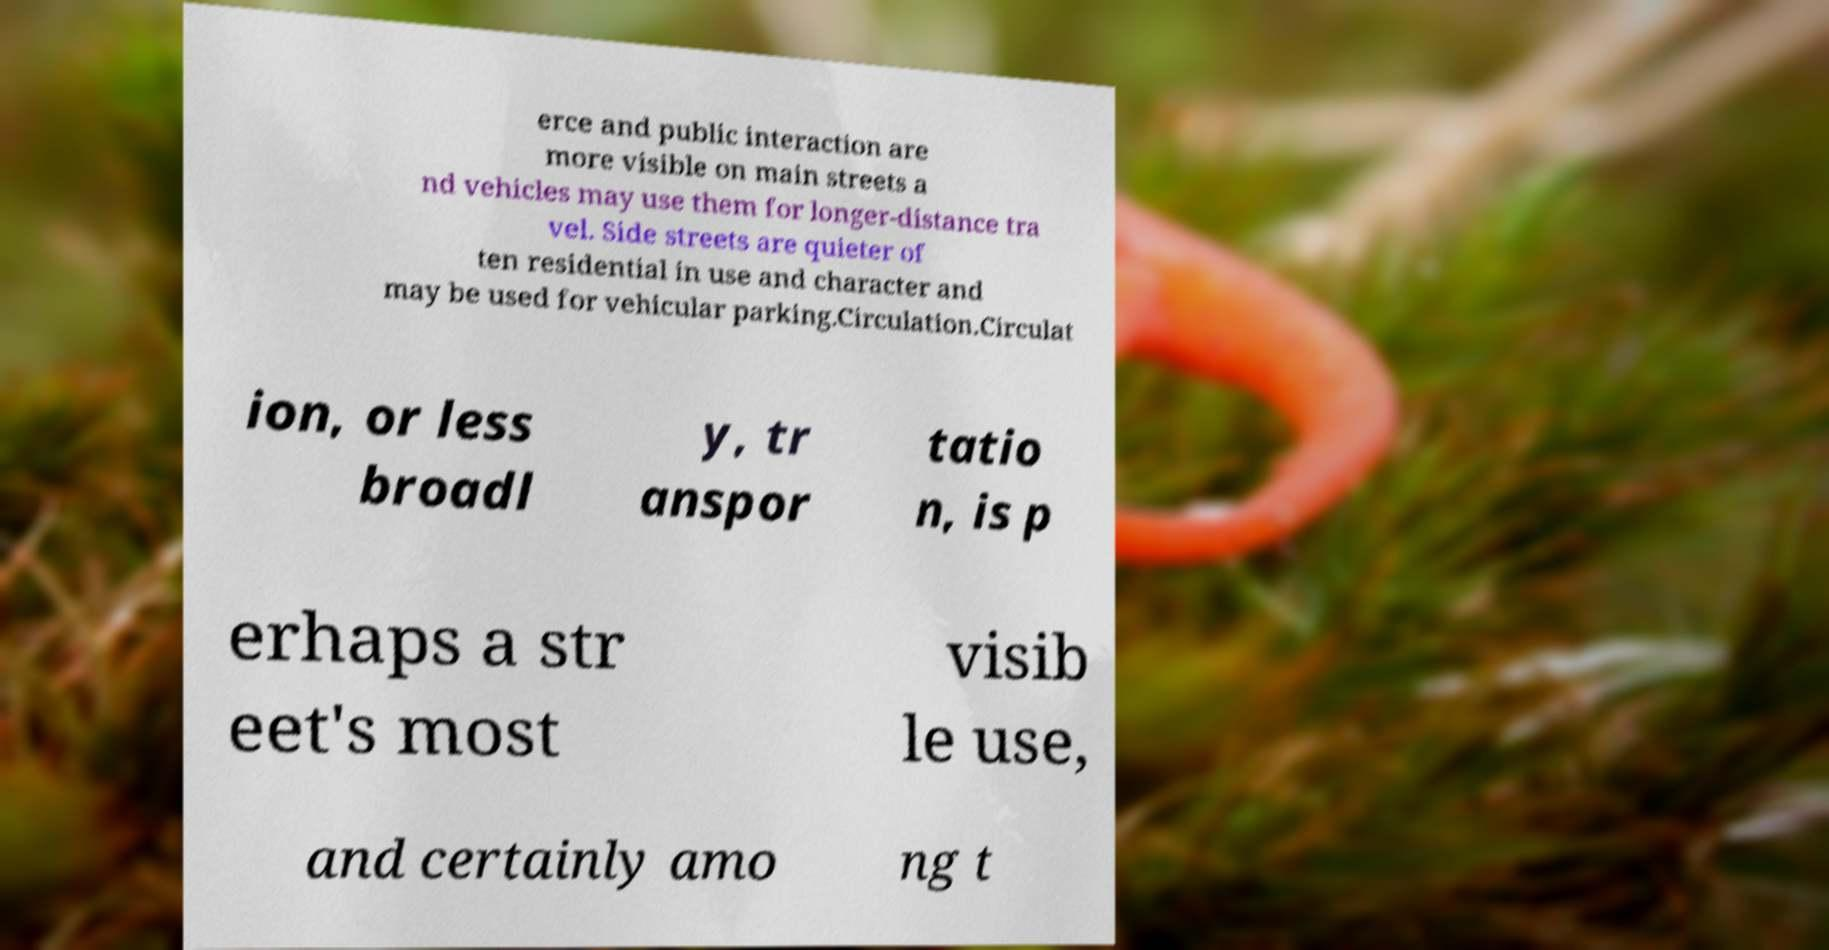Please identify and transcribe the text found in this image. erce and public interaction are more visible on main streets a nd vehicles may use them for longer-distance tra vel. Side streets are quieter of ten residential in use and character and may be used for vehicular parking.Circulation.Circulat ion, or less broadl y, tr anspor tatio n, is p erhaps a str eet's most visib le use, and certainly amo ng t 